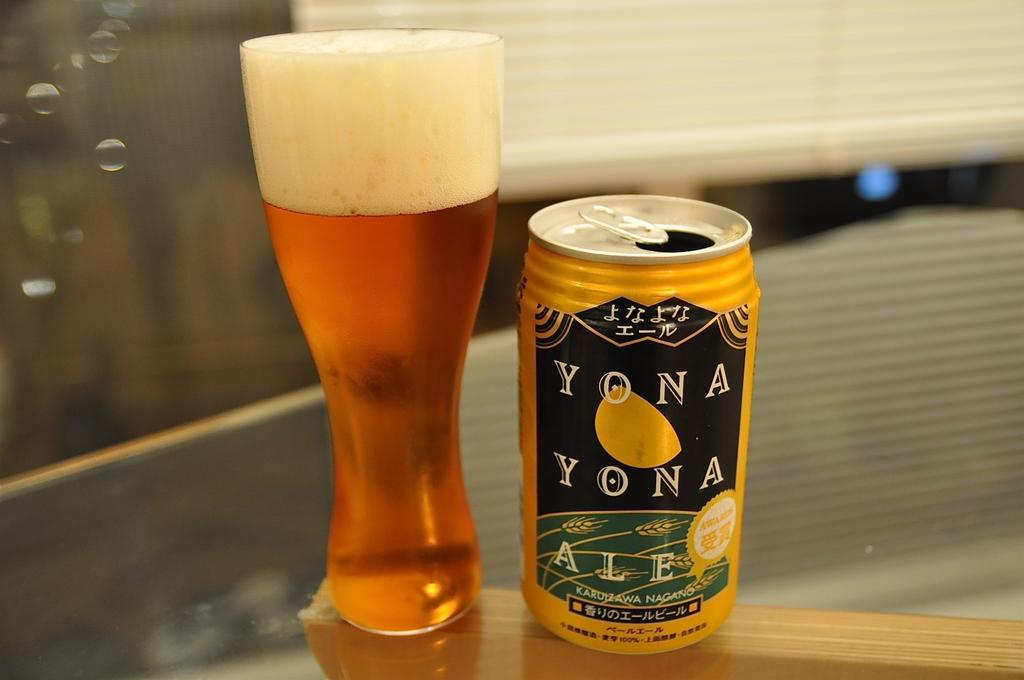<image>
Describe the image concisely. Can of Yona Yona ale next to a tall and full cup of beer. 